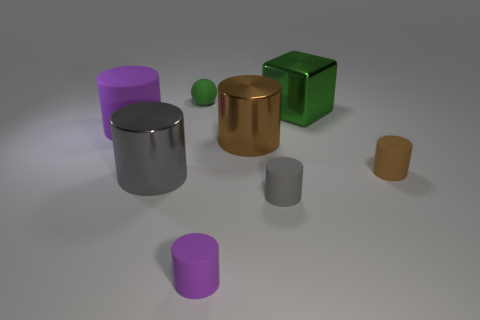Subtract all big brown shiny cylinders. How many cylinders are left? 5 Subtract 1 cylinders. How many cylinders are left? 5 Subtract all purple cylinders. How many cylinders are left? 4 Subtract all yellow cylinders. Subtract all blue balls. How many cylinders are left? 6 Add 1 large rubber cylinders. How many objects exist? 9 Subtract all balls. How many objects are left? 7 Add 7 large shiny objects. How many large shiny objects exist? 10 Subtract 0 blue cylinders. How many objects are left? 8 Subtract all yellow rubber cylinders. Subtract all green blocks. How many objects are left? 7 Add 2 small purple cylinders. How many small purple cylinders are left? 3 